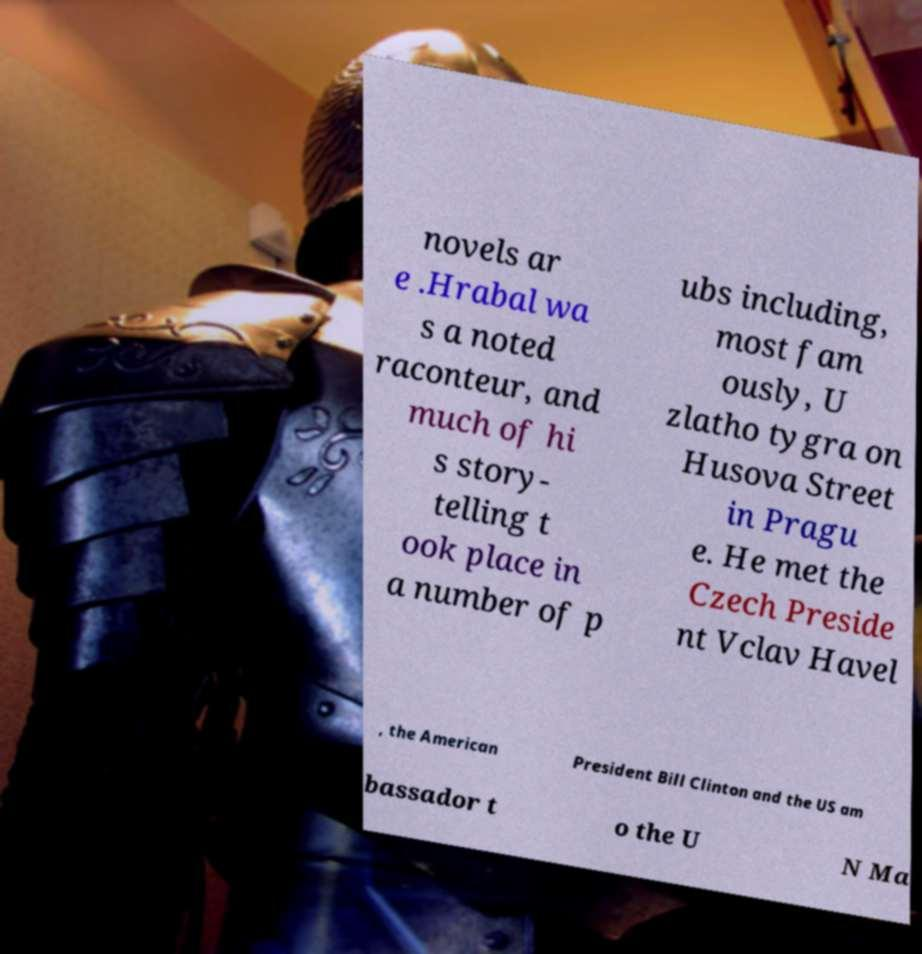Could you extract and type out the text from this image? novels ar e .Hrabal wa s a noted raconteur, and much of hi s story- telling t ook place in a number of p ubs including, most fam ously, U zlatho tygra on Husova Street in Pragu e. He met the Czech Preside nt Vclav Havel , the American President Bill Clinton and the US am bassador t o the U N Ma 